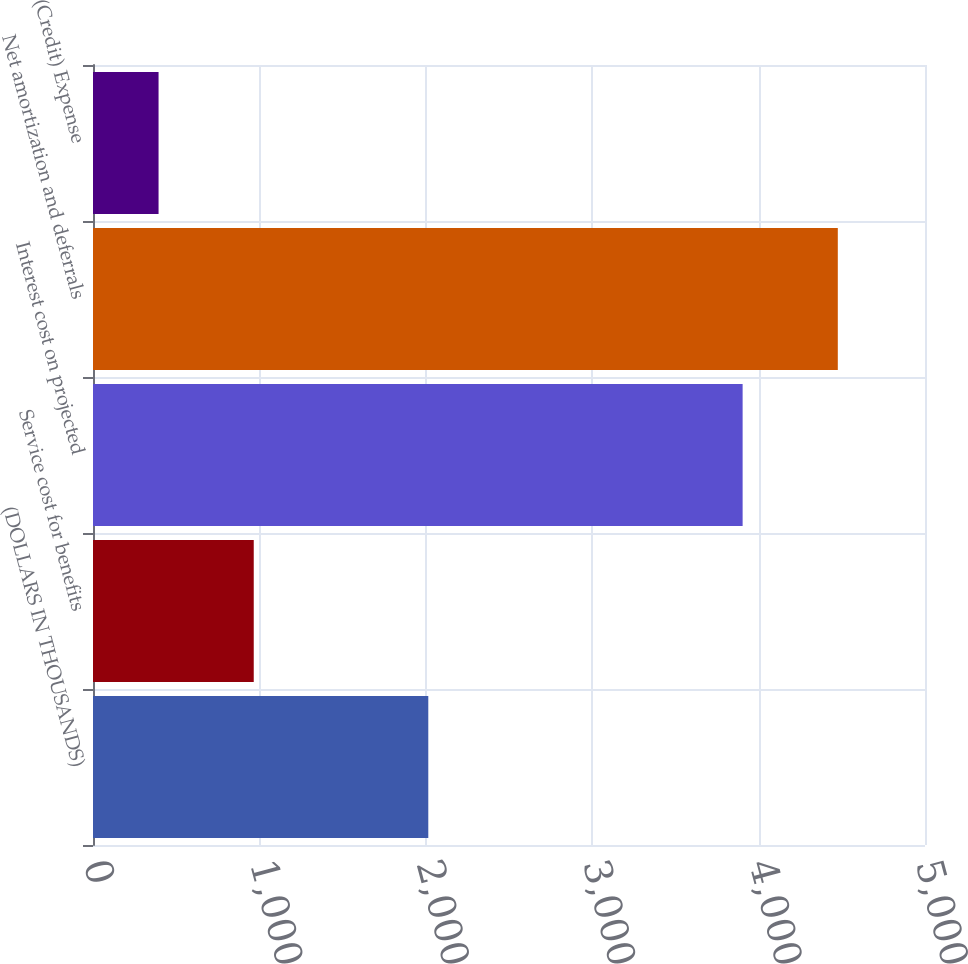Convert chart. <chart><loc_0><loc_0><loc_500><loc_500><bar_chart><fcel>(DOLLARS IN THOUSANDS)<fcel>Service cost for benefits<fcel>Interest cost on projected<fcel>Net amortization and deferrals<fcel>(Credit) Expense<nl><fcel>2015<fcel>966<fcel>3904<fcel>4476<fcel>394<nl></chart> 